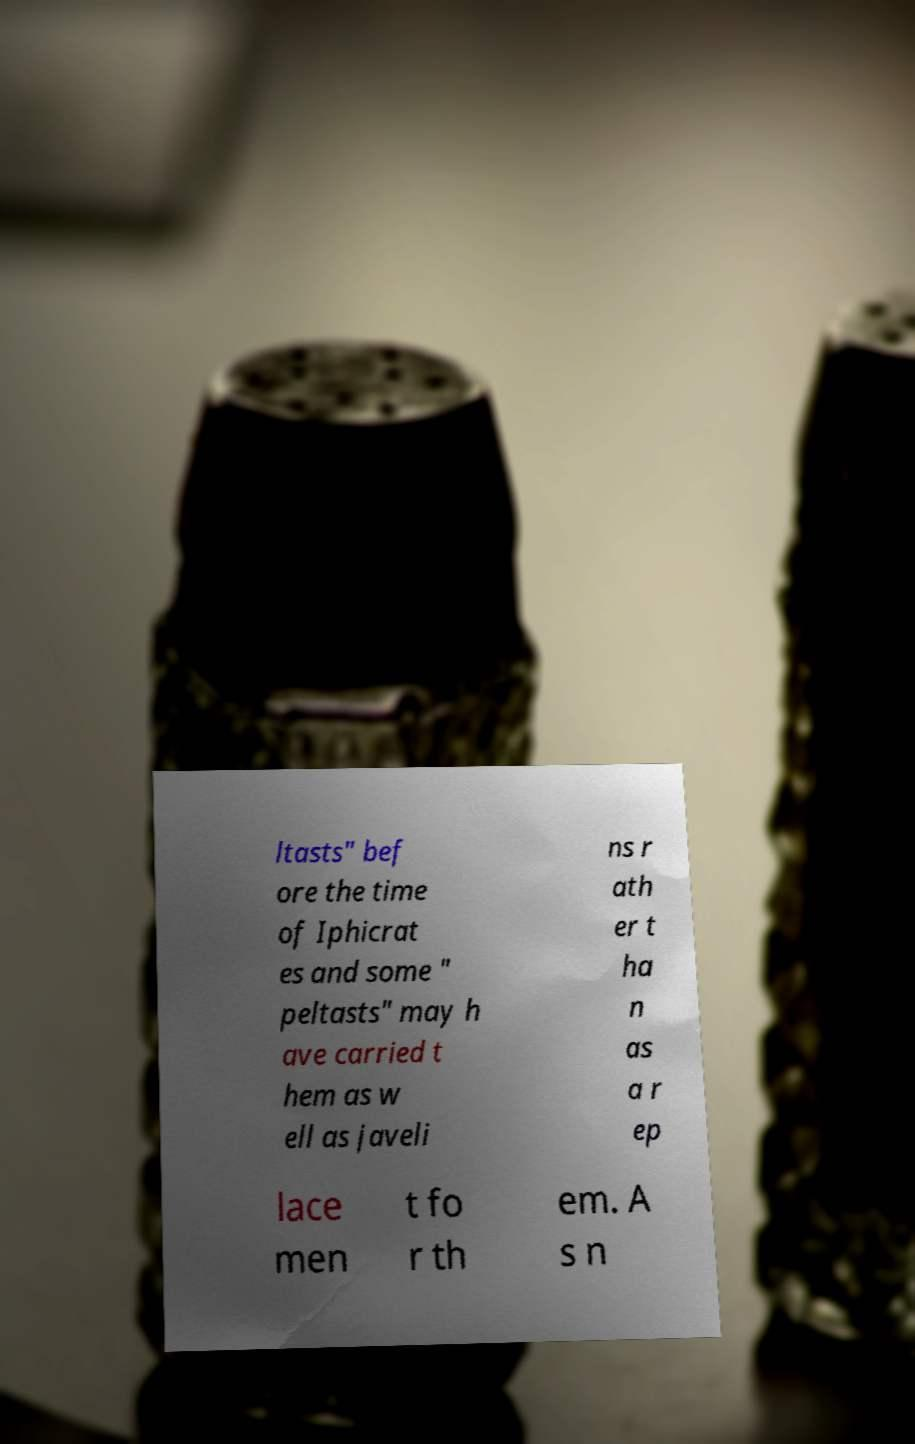I need the written content from this picture converted into text. Can you do that? ltasts" bef ore the time of Iphicrat es and some " peltasts" may h ave carried t hem as w ell as javeli ns r ath er t ha n as a r ep lace men t fo r th em. A s n 